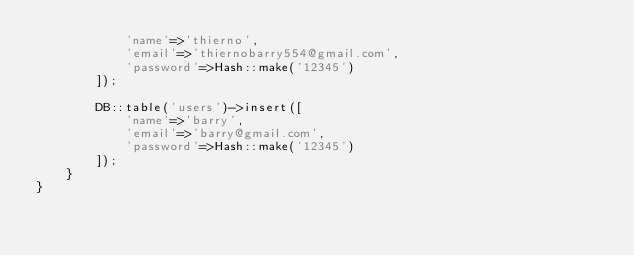Convert code to text. <code><loc_0><loc_0><loc_500><loc_500><_PHP_>            'name'=>'thierno',
            'email'=>'thiernobarry554@gmail.com',
            'password'=>Hash::make('12345')
        ]);

        DB::table('users')->insert([
            'name'=>'barry',
            'email'=>'barry@gmail.com',
            'password'=>Hash::make('12345')
        ]);
    }
}
</code> 